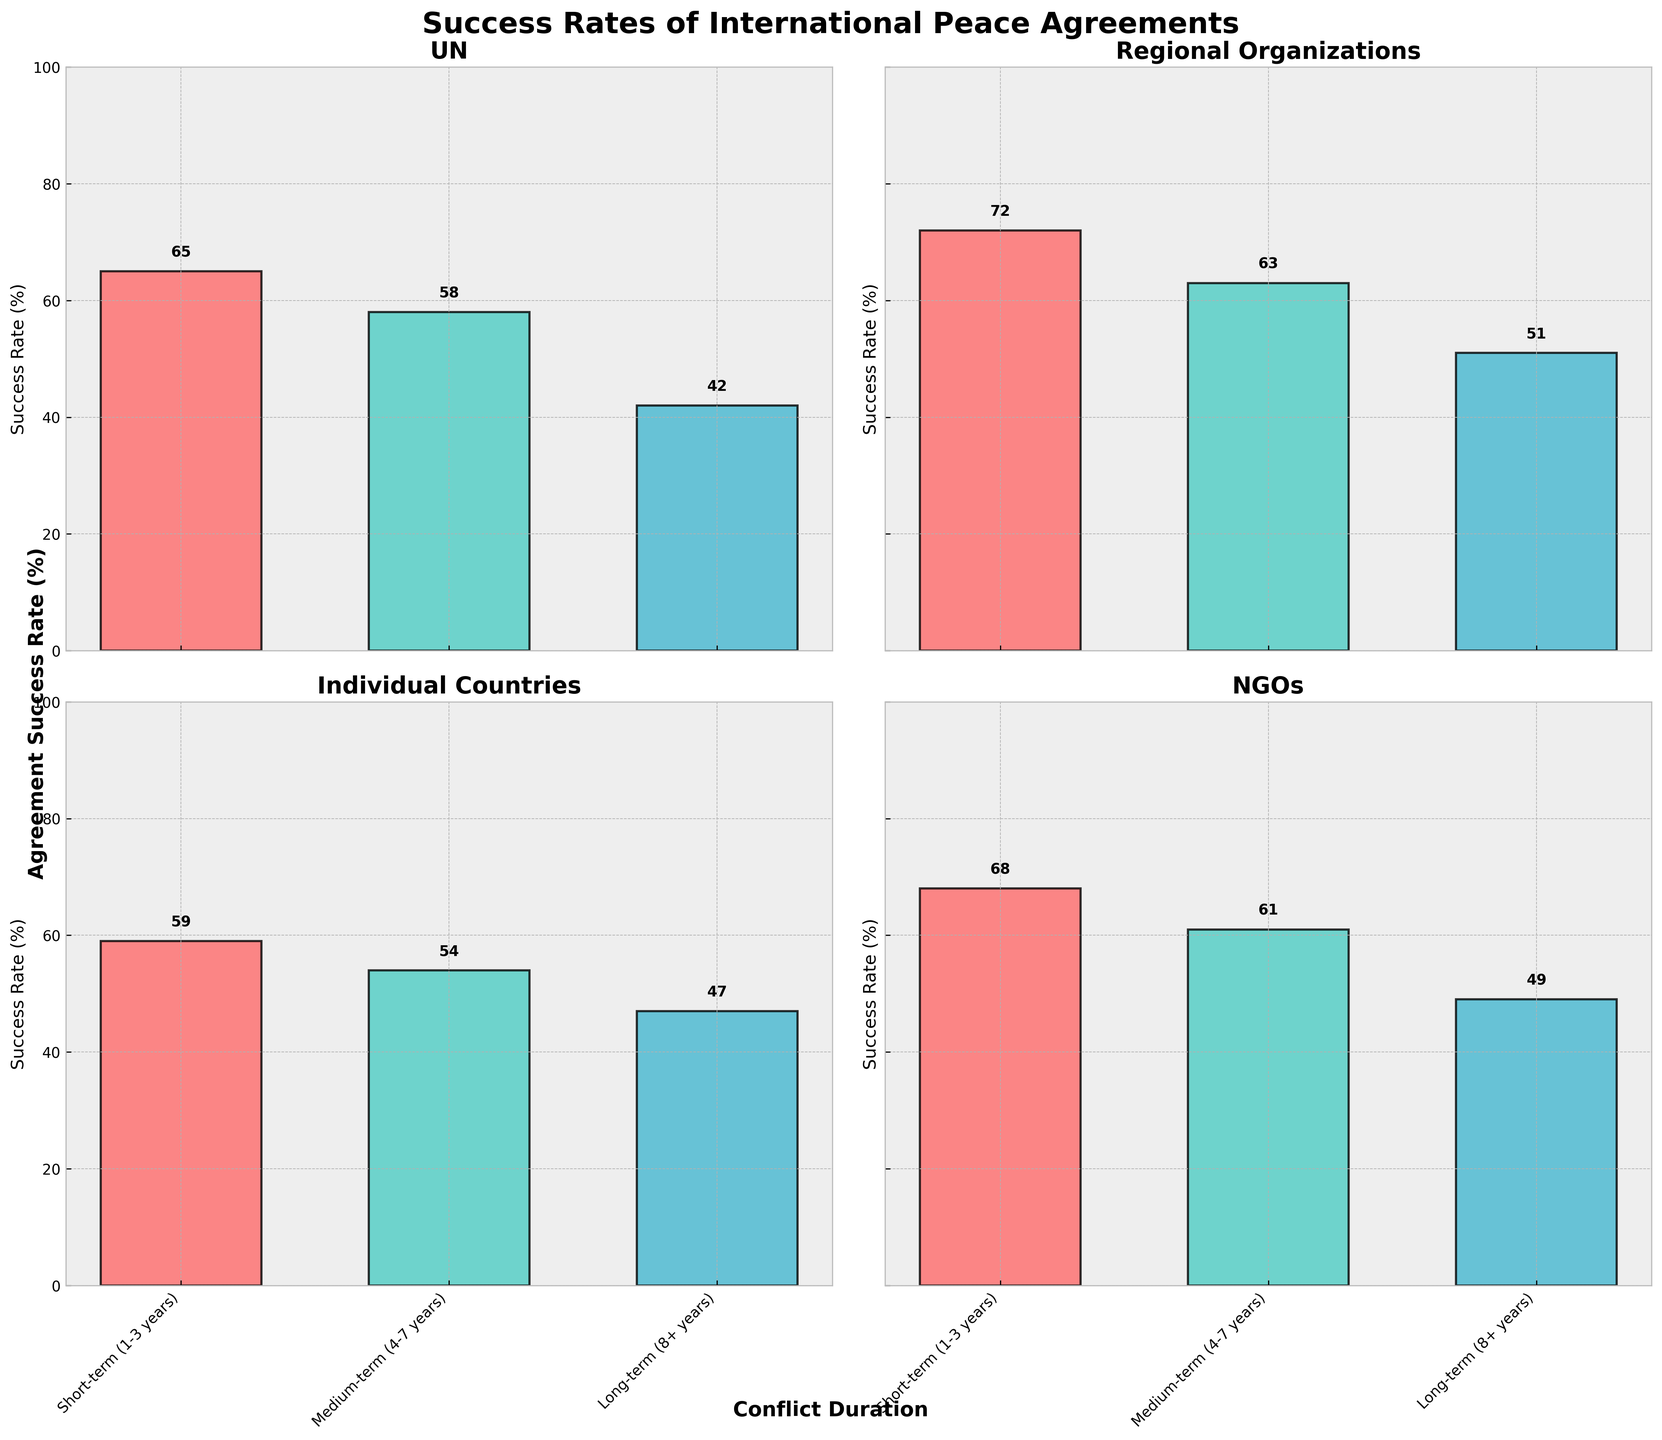what is the success rate of agreements mediated by the UN for short-term conflicts? The success rate can be easily found by looking at the bar representing the short-term (1-3 years) duration within the UN subplot. It shows a value of 65.
Answer: 65 Which mediator type has the highest success rate for short-term conflicts? Compare the bars for short-term (1-3 years) conflicts across all subplots. The highest value on the y-axis corresponds to the "Regional Organizations" mediator type at 72.
Answer: Regional Organizations What is the largest difference in success rates for a single mediator type between short-term and long-term conflicts? For each mediator type, subtract the success rate for long-term (8+ years) from short-term (1-3 years). The largest differences are:
- UN: 65 - 42 = 23
- Regional Organizations: 72 - 51 = 21
- Individual Countries: 59 - 47 = 12
- NGOs: 68 - 49 = 19
The largest difference is for the UN at 23.
Answer: 23 Which mediator has the lowest overall success rate for long-term conflicts? Compare the bars for long-term (8+ years) conflicts across all subplots. The lowest value on the y-axis corresponds to the UN at 42.
Answer: UN How does the success rate of NGOs for medium-term conflicts compare to that of Individual Countries for short-term conflicts? Look at the bars for NGOs for medium-term (4-7 years) and compare to Individual Countries for short-term (1-3 years). NGOs have a success rate of 61, and Individual Countries have a success rate of 59, so NGOs have a slightly higher success rate.
Answer: NGOs have a higher success rate What is the overall trend of success rates as conflict duration increases for Regional Organizations? Analyze the sequence of bars for Regional Organizations as conflict duration goes from short-term to long-term. The success rates decrease from 72 (short-term) to 63 (medium-term) to 51 (long-term).
Answer: Decreasing trend Between individual countries and NGOs, which has a more stable success rate across different conflict durations? Calculate the differences between success rates for short-term, medium-term, and long-term conflicts for both mediator types.
- Individual Countries: 59 - 54 = 5, 54 - 47 = 7 (total variation = 12)
- NGOs: 68 - 61 = 7, 61 - 49 = 12 (total variation = 19)
Individual Countries have a smaller total variation (12) compared to NGOs (19), indicating more stability.
Answer: Individual Countries What does the title of the figure indicate about the content of the plot? The title "Success Rates of International Peace Agreements" indicates that the figure presents data on the success rates of peace agreements, categorized by different mediator types and different conflict durations.
Answer: Success rates of peace agreements 